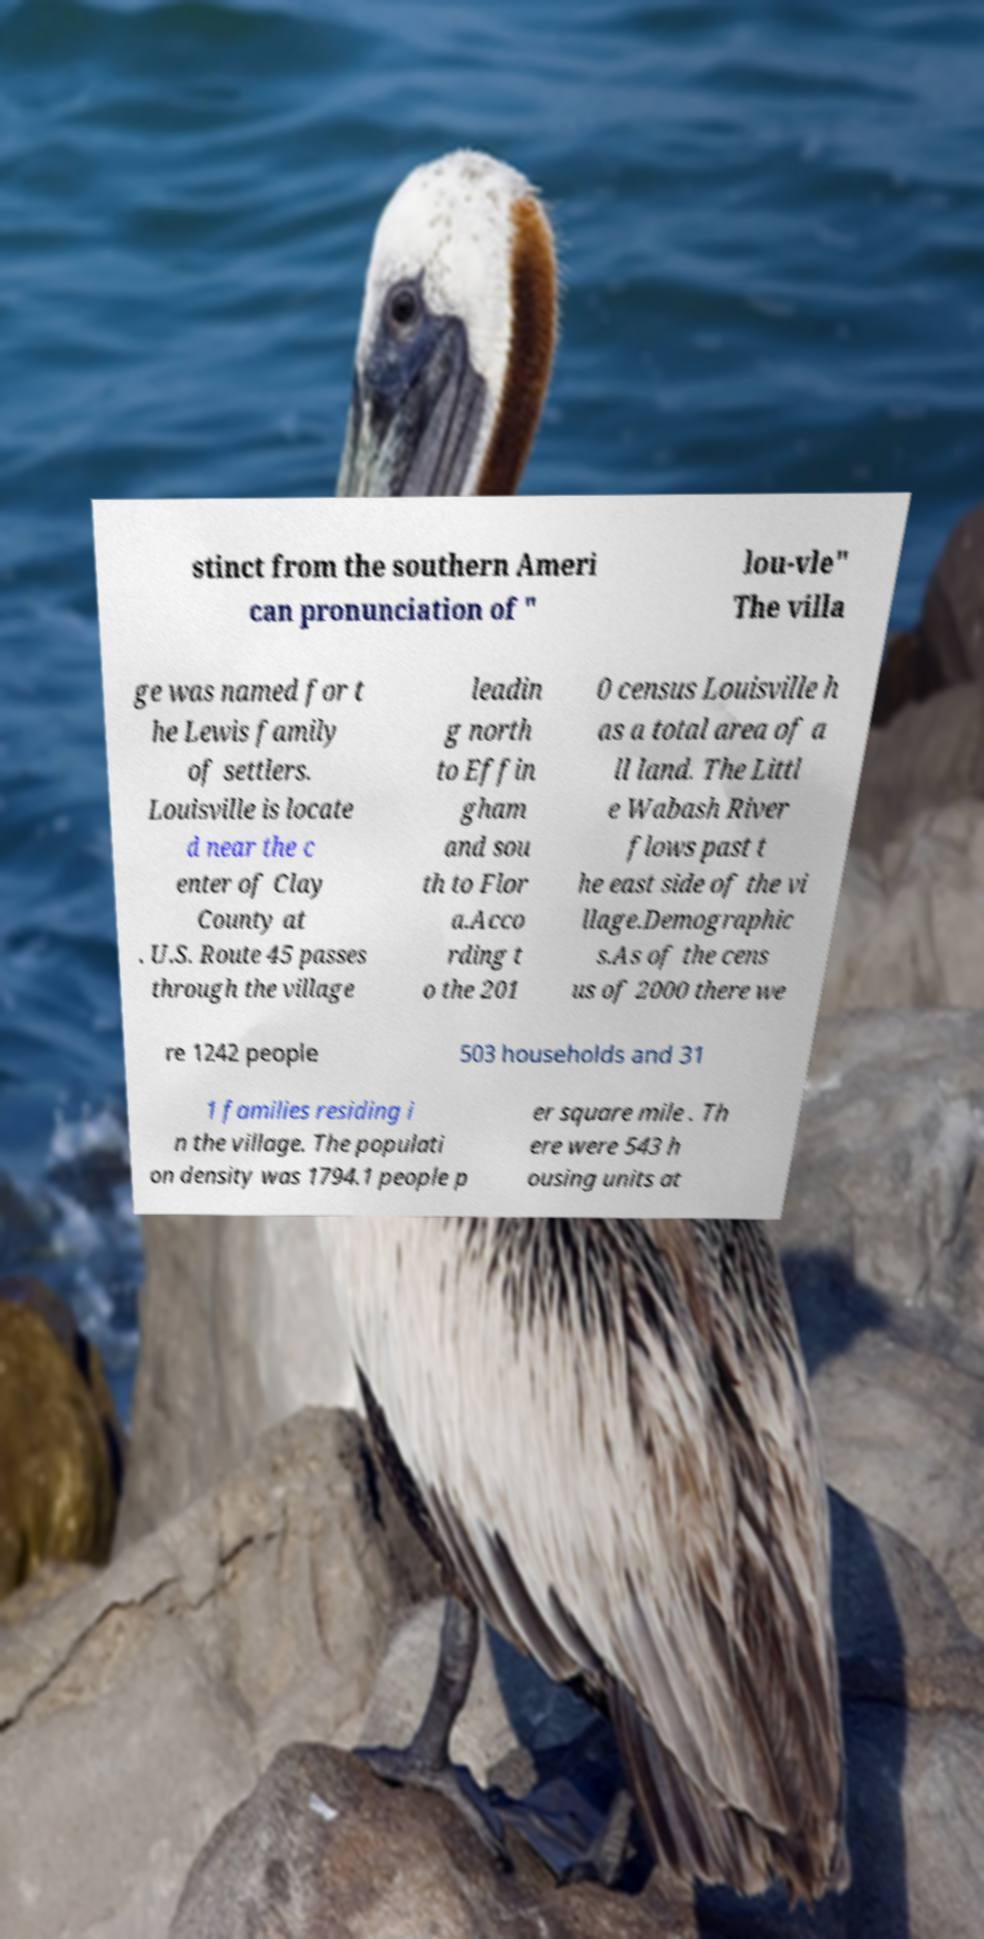I need the written content from this picture converted into text. Can you do that? stinct from the southern Ameri can pronunciation of " lou-vle" The villa ge was named for t he Lewis family of settlers. Louisville is locate d near the c enter of Clay County at . U.S. Route 45 passes through the village leadin g north to Effin gham and sou th to Flor a.Acco rding t o the 201 0 census Louisville h as a total area of a ll land. The Littl e Wabash River flows past t he east side of the vi llage.Demographic s.As of the cens us of 2000 there we re 1242 people 503 households and 31 1 families residing i n the village. The populati on density was 1794.1 people p er square mile . Th ere were 543 h ousing units at 